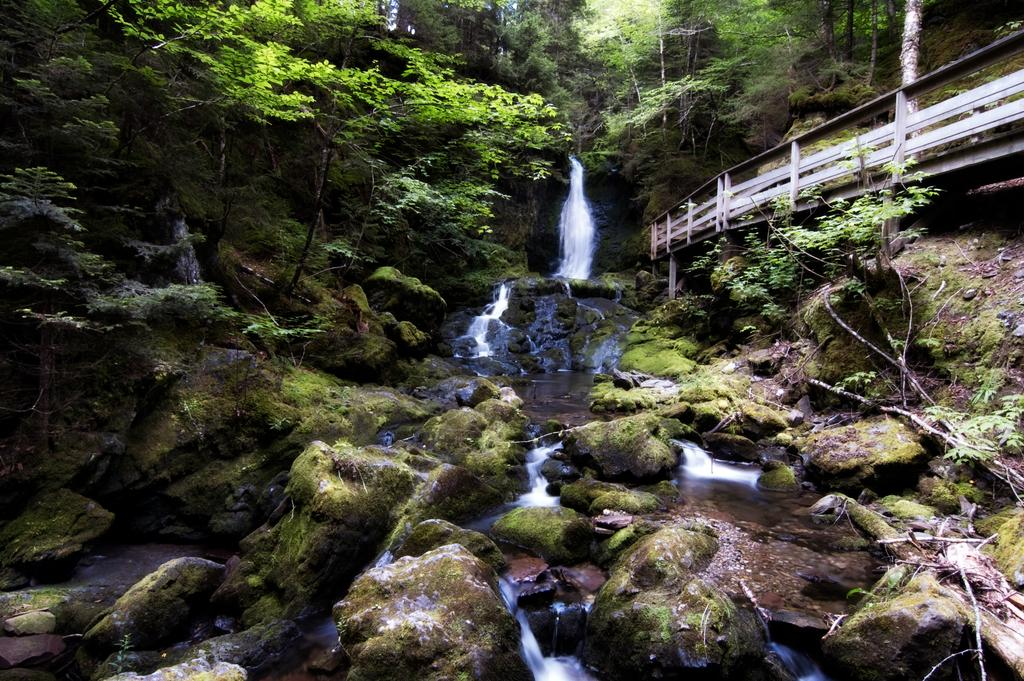What type of natural formation can be seen in the image? There are rocks with algae in the image. What can be seen in the background of the image? There is a waterfall and many trees in the background of the image. Can you describe any man-made structures in the image? There is a railing on the right side of the image. What type of basin can be seen in the image? There is no basin present in the image. 